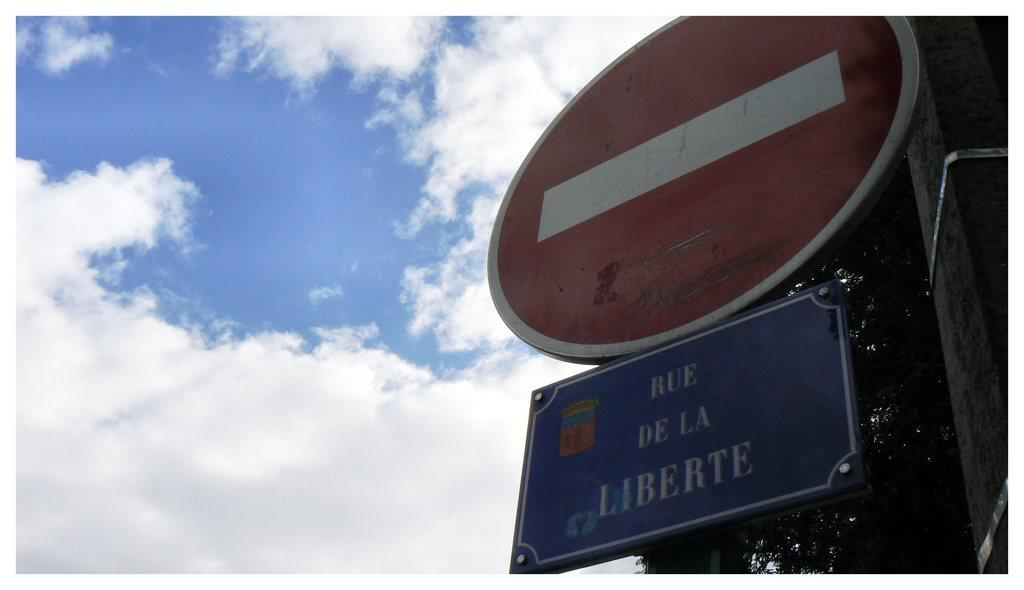<image>
Create a compact narrative representing the image presented. A round red and white sign with a white rectangle on it is above a sign that says "Rue De La Liberte". 